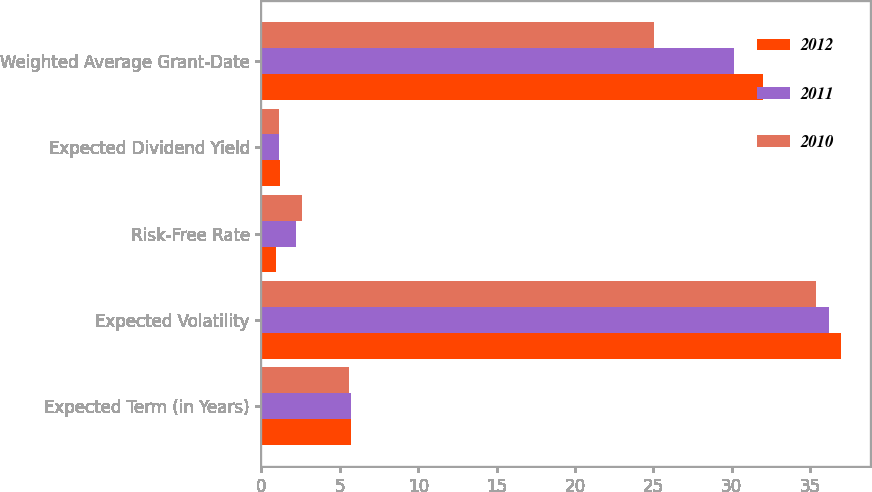Convert chart to OTSL. <chart><loc_0><loc_0><loc_500><loc_500><stacked_bar_chart><ecel><fcel>Expected Term (in Years)<fcel>Expected Volatility<fcel>Risk-Free Rate<fcel>Expected Dividend Yield<fcel>Weighted Average Grant-Date<nl><fcel>2012<fcel>5.7<fcel>37<fcel>0.9<fcel>1.2<fcel>31.98<nl><fcel>2011<fcel>5.7<fcel>36.2<fcel>2.2<fcel>1.1<fcel>30.17<nl><fcel>2010<fcel>5.6<fcel>35.4<fcel>2.6<fcel>1.1<fcel>25.05<nl></chart> 